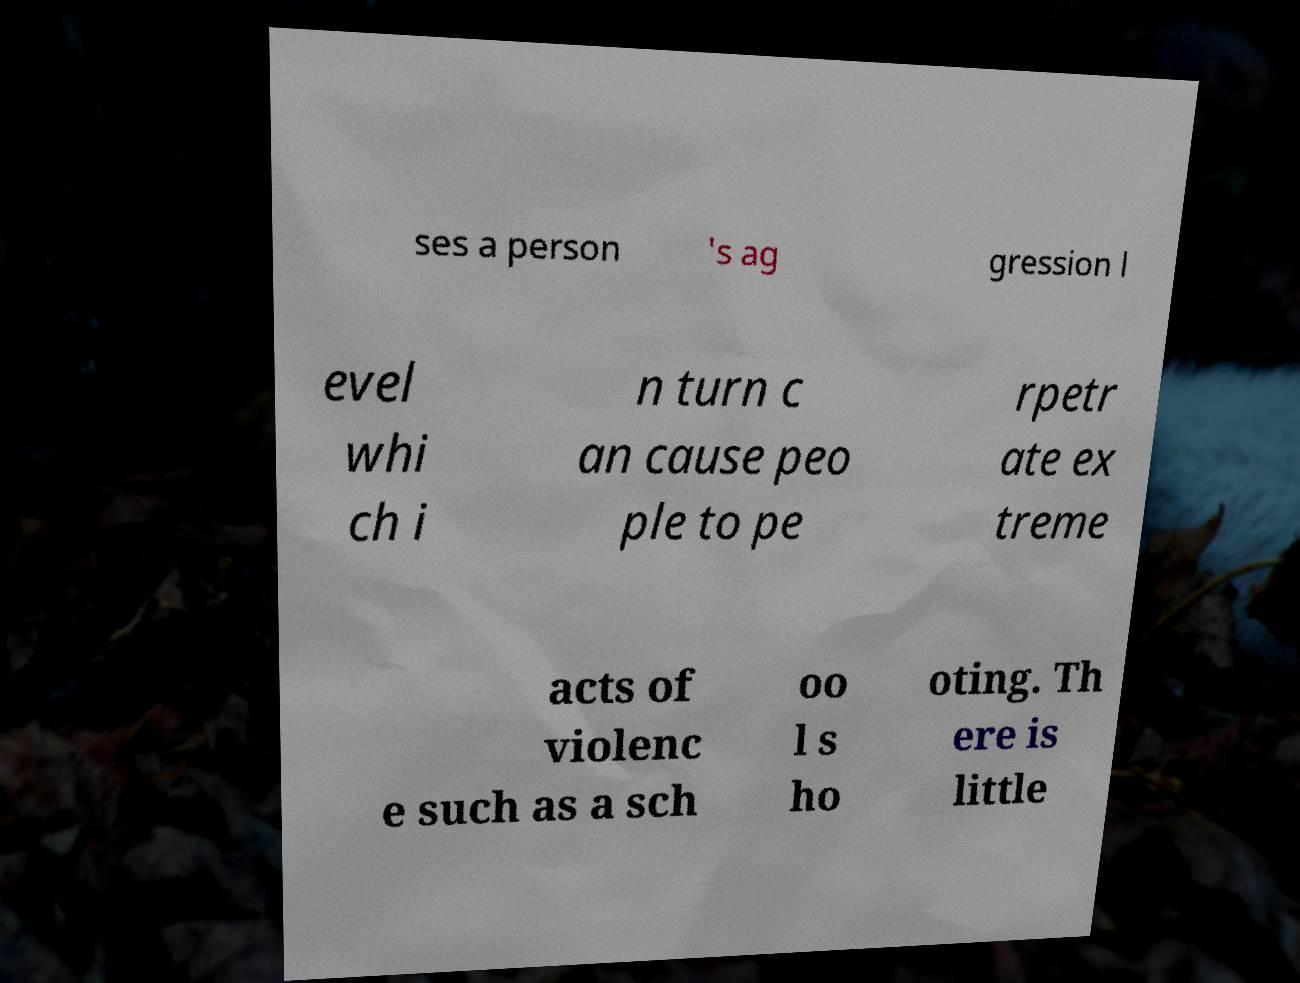Please read and relay the text visible in this image. What does it say? ses a person 's ag gression l evel whi ch i n turn c an cause peo ple to pe rpetr ate ex treme acts of violenc e such as a sch oo l s ho oting. Th ere is little 